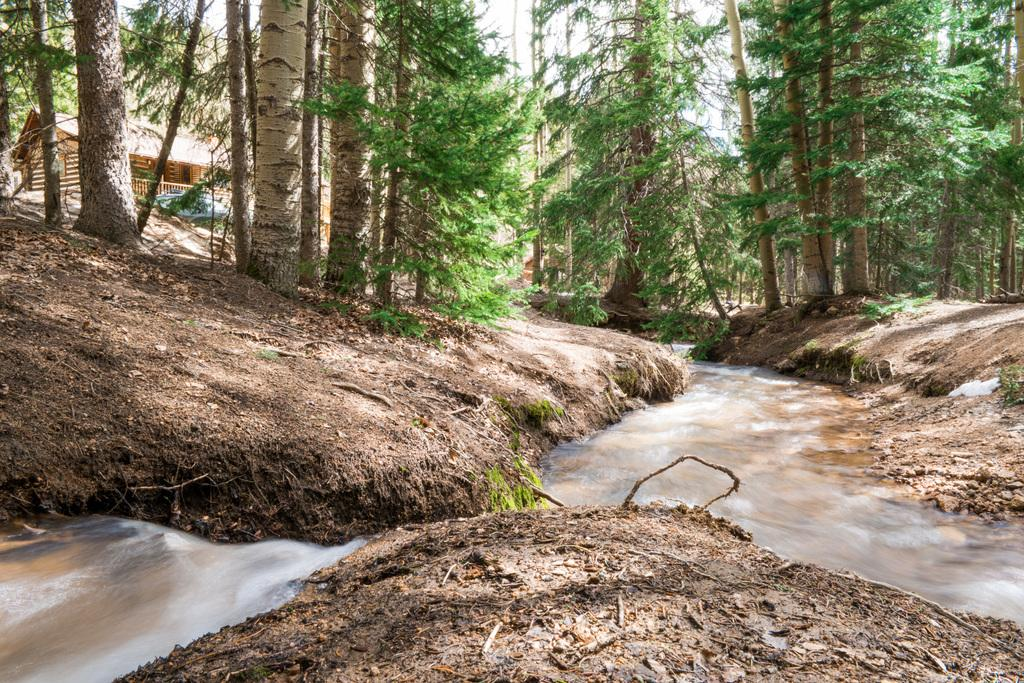What type of terrain is visible in the image? Ground and water are visible in the image. What type of vegetation can be seen in the image? There are trees in the image. What type of structure is present in the image? There is a house in the image. What is visible in the background of the image? The sky is visible in the background of the image. Where is the hook used to hang the sack in the image? There is no hook or sack present in the image. What type of lock is securing the door of the house in the image? There is no lock visible on the house in the image. 